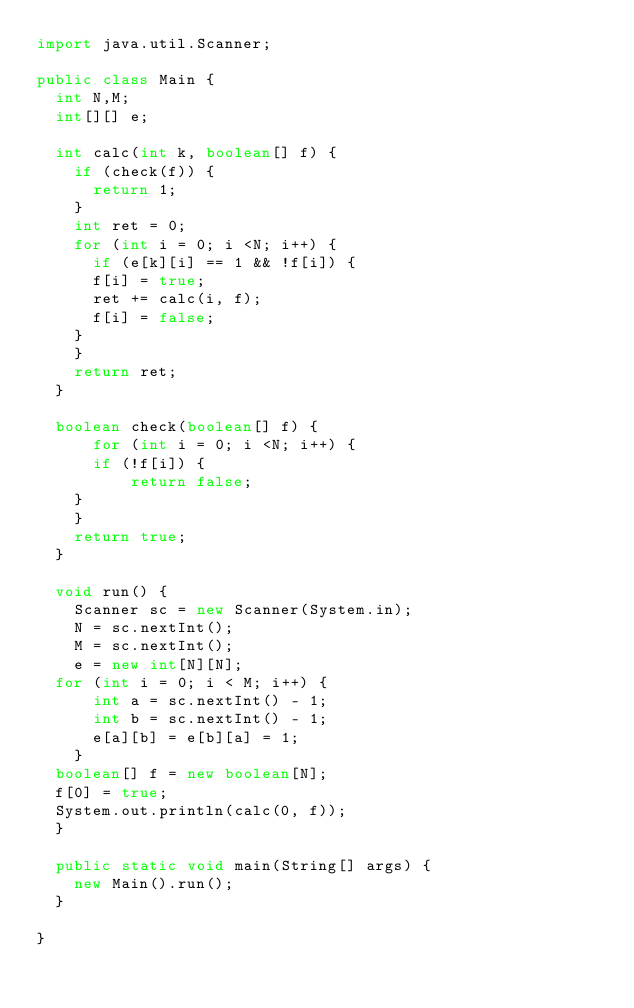<code> <loc_0><loc_0><loc_500><loc_500><_Java_>import java.util.Scanner;
 
public class Main {
  int N,M;
  int[][] e;
  
  int calc(int k, boolean[] f) {
    if (check(f)) {
      return 1;
    }
    int ret = 0;
	  for (int i = 0; i <N; i++) {
	    if (e[k][i] == 1 && !f[i]) {
		  f[i] = true;
		  ret += calc(i, f);
		  f[i] = false;
		}
	  }
	  return ret;
	}
 
	boolean check(boolean[] f) {
      for (int i = 0; i <N; i++) {
	    if (!f[i]) {
          return false;
		}
	  }
	  return true;
	}
  
  void run() {
    Scanner sc = new Scanner(System.in);
    N = sc.nextInt();  
    M = sc.nextInt();
    e = new int[N][N];
	for (int i = 0; i < M; i++) {
      int a = sc.nextInt() - 1;
      int b = sc.nextInt() - 1;
      e[a][b] = e[b][a] = 1;
    }
	boolean[] f = new boolean[N];
	f[0] = true;
	System.out.println(calc(0, f));
	}
  
  public static void main(String[] args) {
    new Main().run();
  }
  
}</code> 